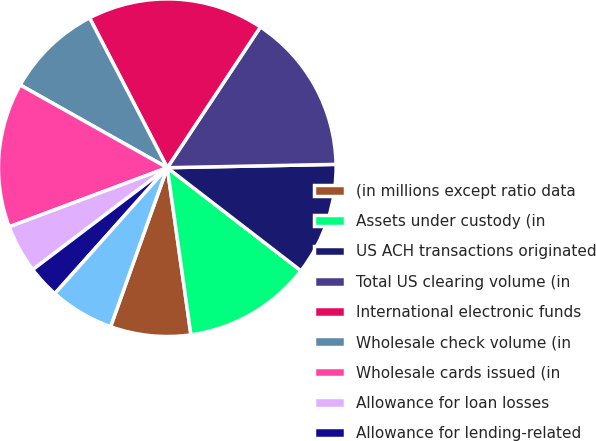<chart> <loc_0><loc_0><loc_500><loc_500><pie_chart><fcel>(in millions except ratio data<fcel>Assets under custody (in<fcel>US ACH transactions originated<fcel>Total US clearing volume (in<fcel>International electronic funds<fcel>Wholesale check volume (in<fcel>Wholesale cards issued (in<fcel>Allowance for loan losses<fcel>Allowance for lending-related<fcel>Total allowance for credit<nl><fcel>7.69%<fcel>12.31%<fcel>10.77%<fcel>15.38%<fcel>16.92%<fcel>9.23%<fcel>13.85%<fcel>4.62%<fcel>3.08%<fcel>6.15%<nl></chart> 